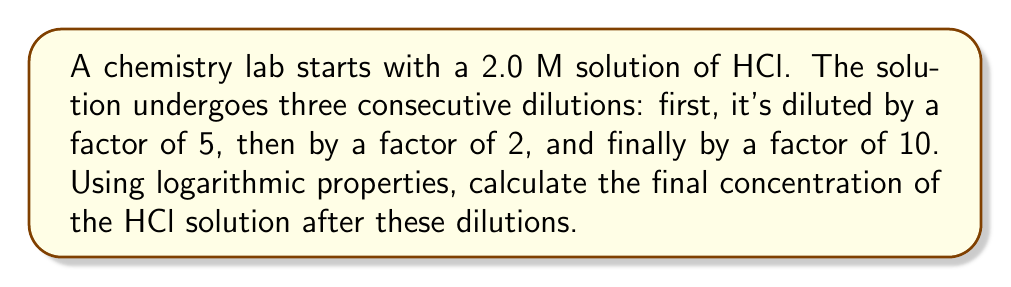What is the answer to this math problem? Let's approach this step-by-step:

1) The initial concentration is 2.0 M.

2) We can represent each dilution as a division:
   - First dilution: $2.0 \div 5$
   - Second dilution: $\div 2$
   - Third dilution: $\div 10$

3) We can write this as a single expression:

   $$ \text{Final Concentration} = \frac{2.0}{5 \cdot 2 \cdot 10} $$

4) This can be rewritten as:

   $$ \text{Final Concentration} = 2.0 \cdot \frac{1}{5} \cdot \frac{1}{2} \cdot \frac{1}{10} $$

5) Now, let's apply logarithms to both sides:

   $$ \log(\text{Final Concentration}) = \log(2.0) + \log(\frac{1}{5}) + \log(\frac{1}{2}) + \log(\frac{1}{10}) $$

6) Using the logarithm property $\log(\frac{1}{x}) = -\log(x)$, we get:

   $$ \log(\text{Final Concentration}) = \log(2.0) - \log(5) - \log(2) - \log(10) $$

7) Calculate each logarithm:
   $\log(2.0) \approx 0.301$
   $\log(5) \approx 0.699$
   $\log(2) \approx 0.301$
   $\log(10) = 1$

8) Substitute these values:

   $$ \log(\text{Final Concentration}) = 0.301 - 0.699 - 0.301 - 1 = -1.699 $$

9) To get the final concentration, we need to apply the inverse operation (antilog or 10^x):

   $$ \text{Final Concentration} = 10^{-1.699} \approx 0.02 \text{ M} $$
Answer: The final concentration of the HCl solution after the three dilutions is approximately 0.02 M. 